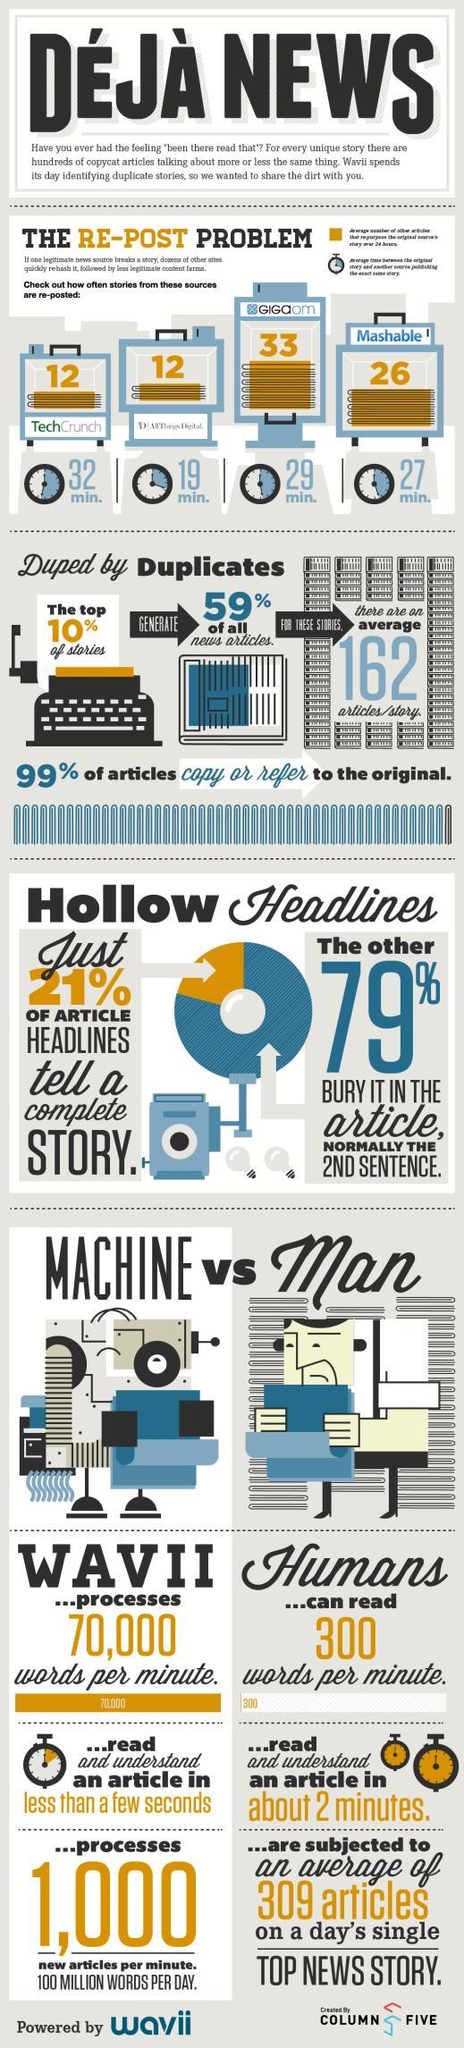What is the number of words machines can read per minute, 300, 1,000, or 70,000?
Answer the question with a short phrase. 70,000 